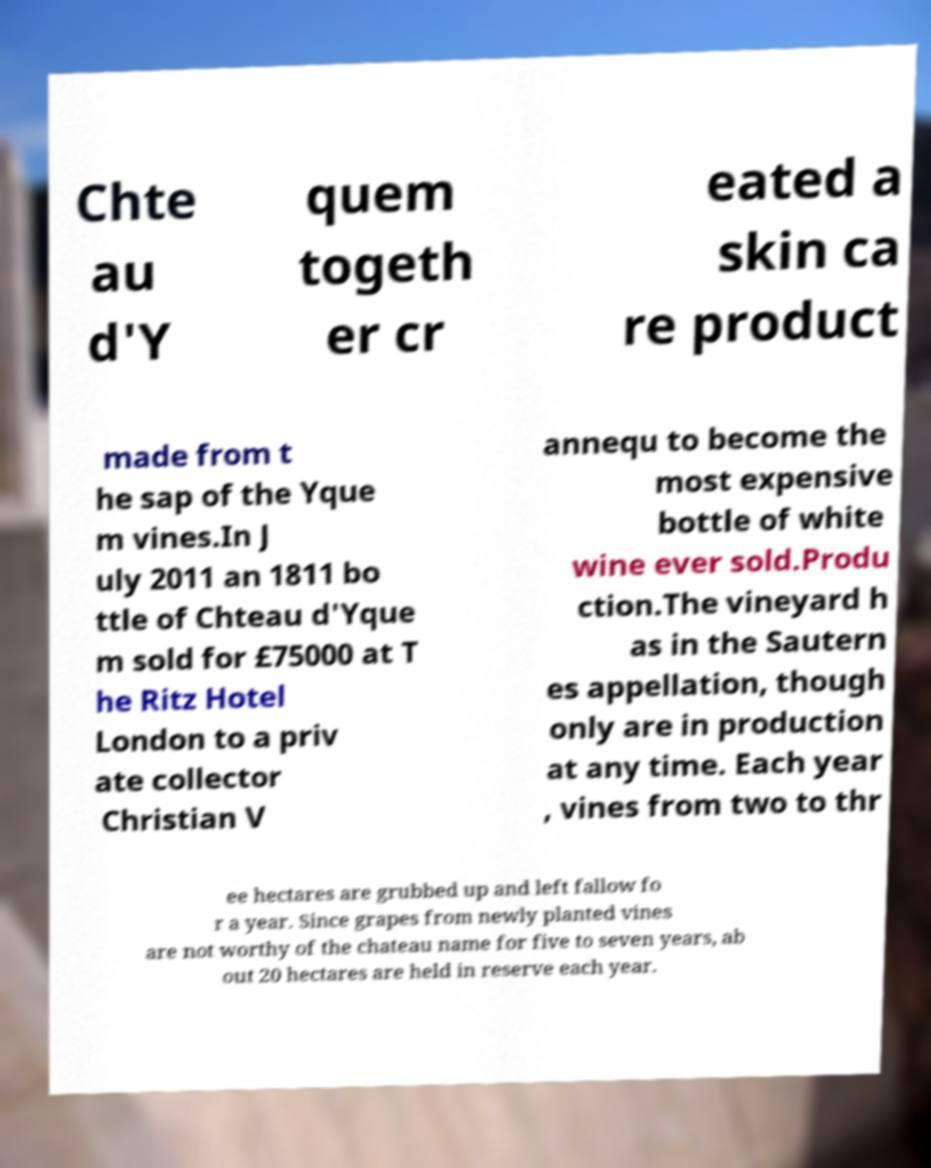Can you accurately transcribe the text from the provided image for me? Chte au d'Y quem togeth er cr eated a skin ca re product made from t he sap of the Yque m vines.In J uly 2011 an 1811 bo ttle of Chteau d'Yque m sold for £75000 at T he Ritz Hotel London to a priv ate collector Christian V annequ to become the most expensive bottle of white wine ever sold.Produ ction.The vineyard h as in the Sautern es appellation, though only are in production at any time. Each year , vines from two to thr ee hectares are grubbed up and left fallow fo r a year. Since grapes from newly planted vines are not worthy of the chateau name for five to seven years, ab out 20 hectares are held in reserve each year. 